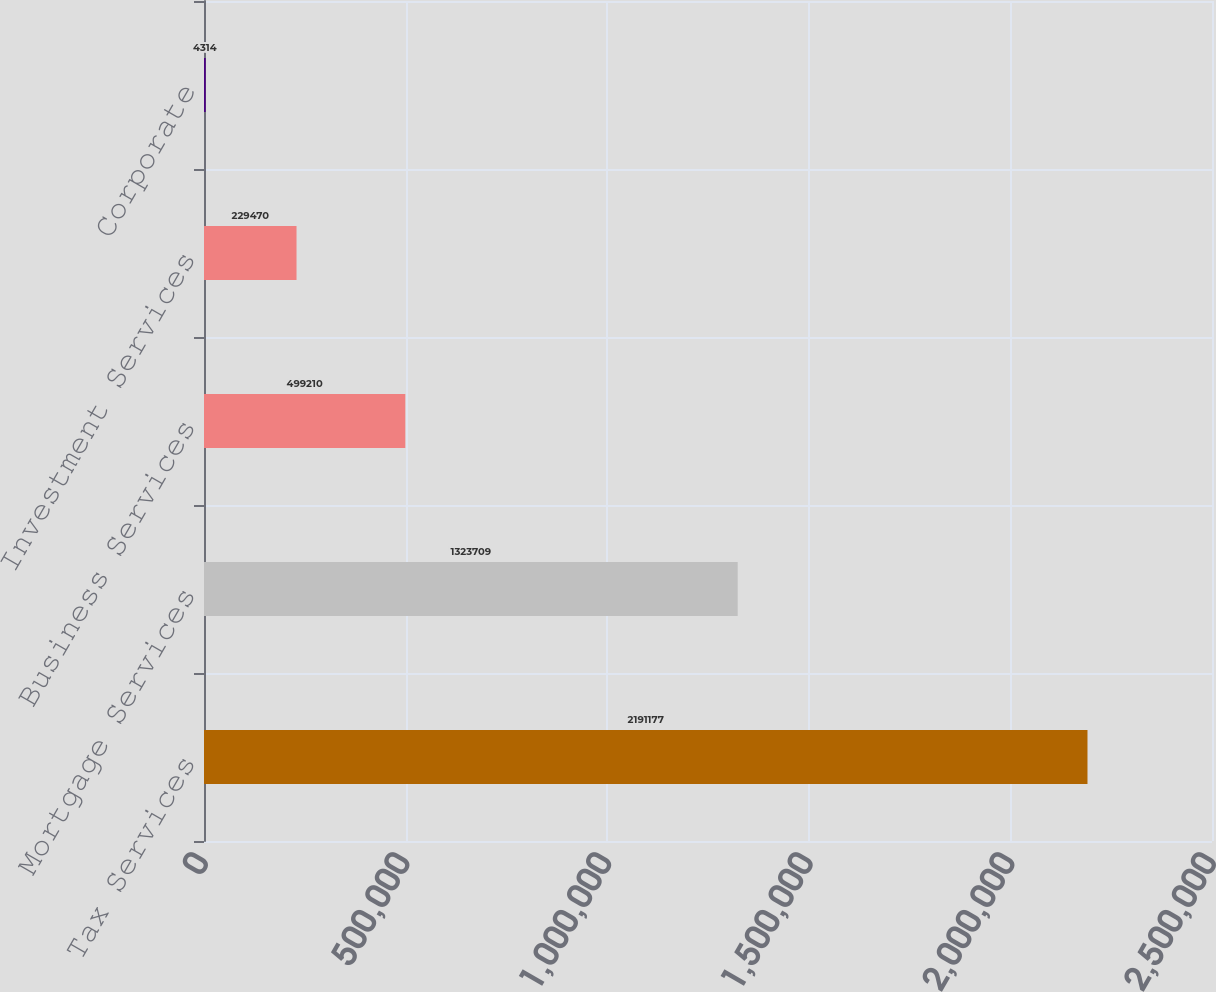Convert chart to OTSL. <chart><loc_0><loc_0><loc_500><loc_500><bar_chart><fcel>Tax Services<fcel>Mortgage Services<fcel>Business Services<fcel>Investment Services<fcel>Corporate<nl><fcel>2.19118e+06<fcel>1.32371e+06<fcel>499210<fcel>229470<fcel>4314<nl></chart> 